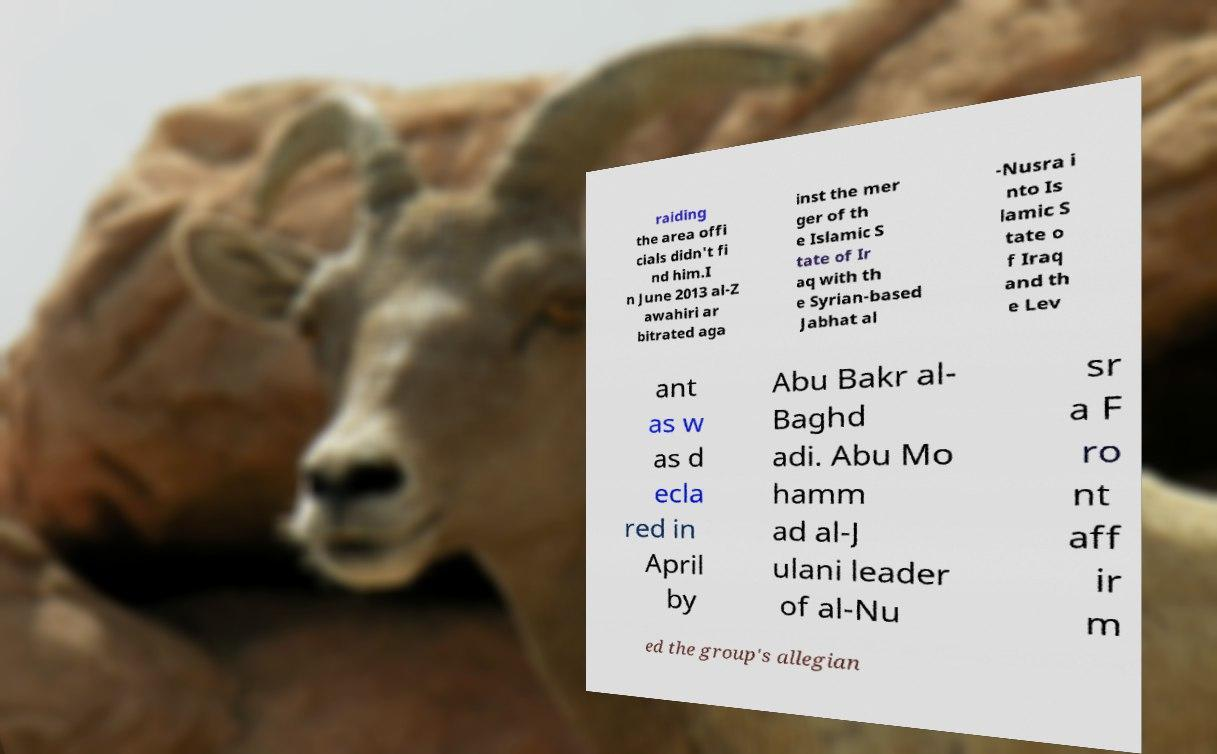What messages or text are displayed in this image? I need them in a readable, typed format. raiding the area offi cials didn't fi nd him.I n June 2013 al-Z awahiri ar bitrated aga inst the mer ger of th e Islamic S tate of Ir aq with th e Syrian-based Jabhat al -Nusra i nto Is lamic S tate o f Iraq and th e Lev ant as w as d ecla red in April by Abu Bakr al- Baghd adi. Abu Mo hamm ad al-J ulani leader of al-Nu sr a F ro nt aff ir m ed the group's allegian 